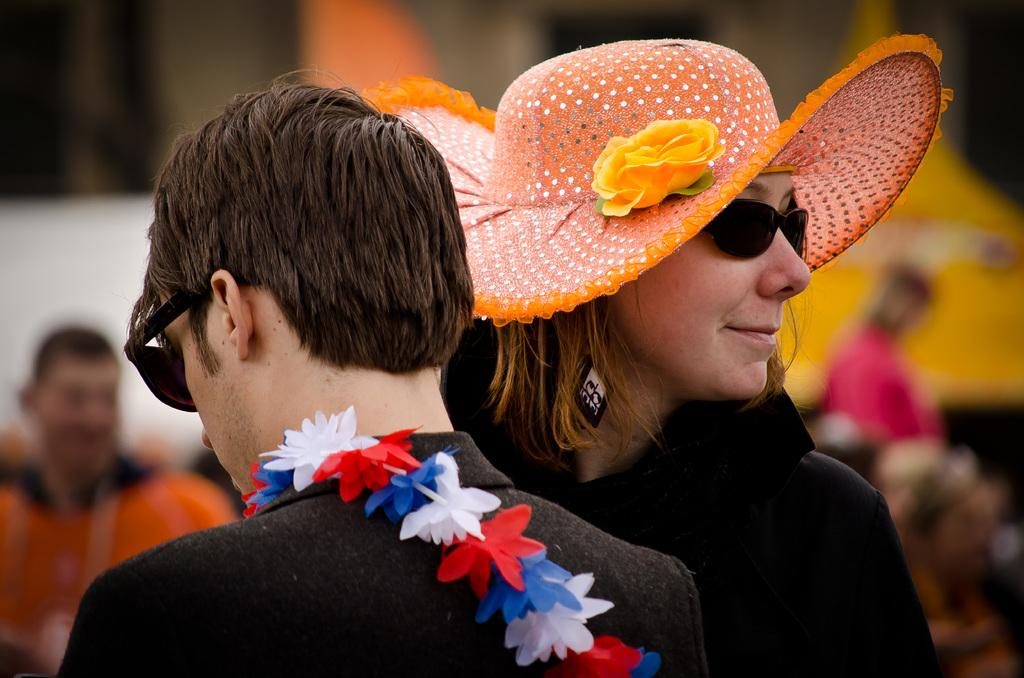What can be seen in the image? There are people standing in the image. How many cows are visible in the image? There are no cows present in the image; it only features people standing. What type of knife is being used by the people in the image? There is no knife visible in the image. What kind of balls are being played with in the image? There are no balls present in the image. 